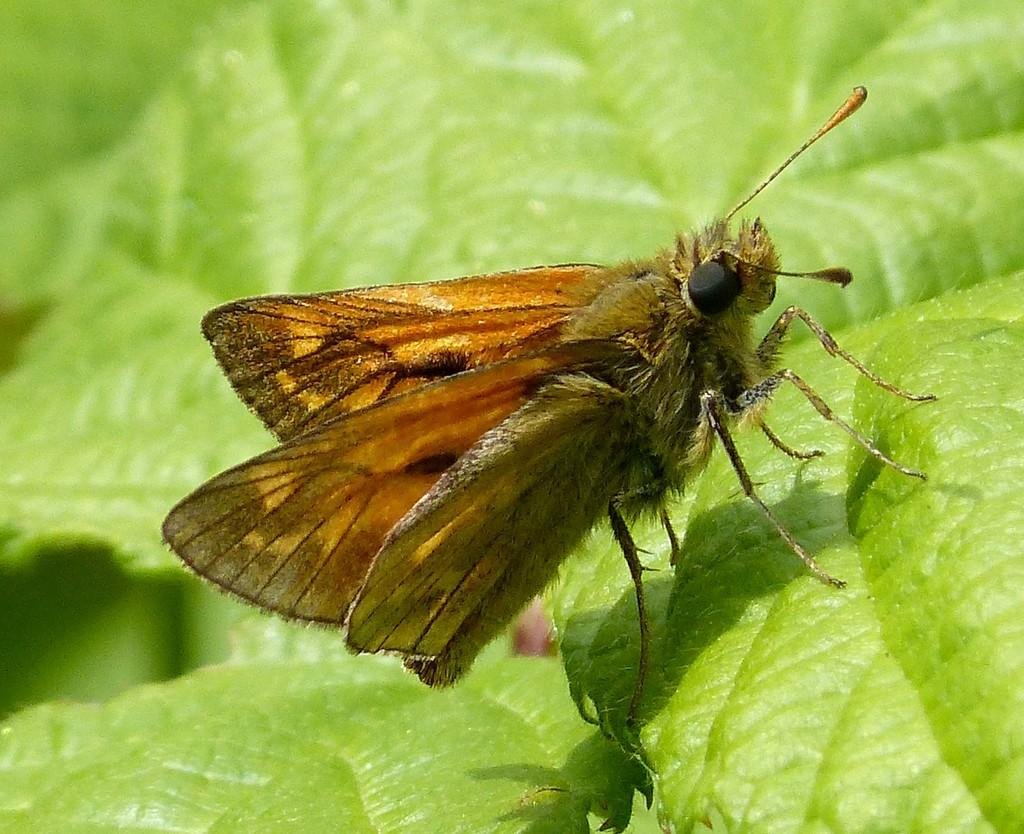What type of natural elements can be seen in the image? There are leaves in the image. Can you describe the interaction between the insect and the leaf? There is an insect on a leaf in the image. What is the visual effect of the background in the image? The background of the image is blurred. What type of sofa can be seen in the image? There is no sofa present in the image. Can you describe the chin of the insect in the image? There is no insect with a chin in the image, as insects do not have chins. 